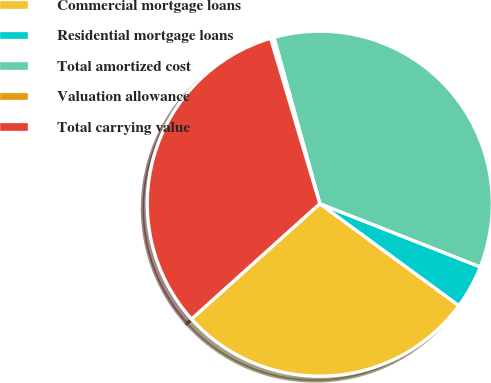<chart> <loc_0><loc_0><loc_500><loc_500><pie_chart><fcel>Commercial mortgage loans<fcel>Residential mortgage loans<fcel>Total amortized cost<fcel>Valuation allowance<fcel>Total carrying value<nl><fcel>28.28%<fcel>4.09%<fcel>35.27%<fcel>0.31%<fcel>32.06%<nl></chart> 